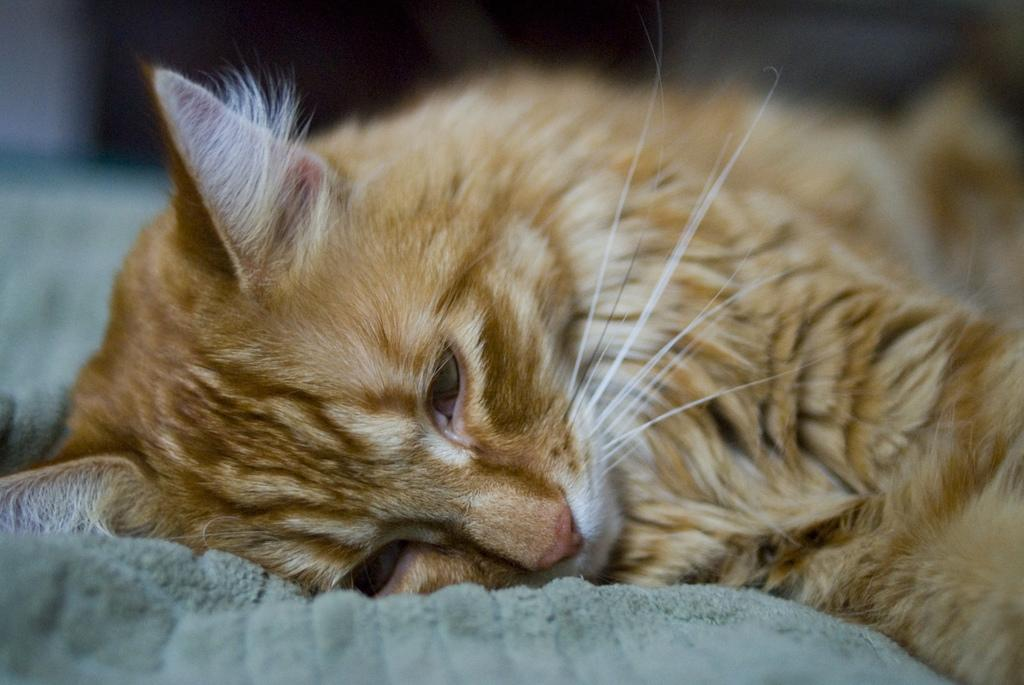Where was the image taken? The image was taken indoors. What is located at the bottom of the image? There is a towel at the bottom of the image. What can be seen on the towel in the image? There is a cat lying on the towel on the right side of the image. Is there a fire burning in the image? No, there is no fire present in the image. What type of pocket can be seen on the cat in the image? There are no pockets on the cat in the image, as cats do not wear clothing. 